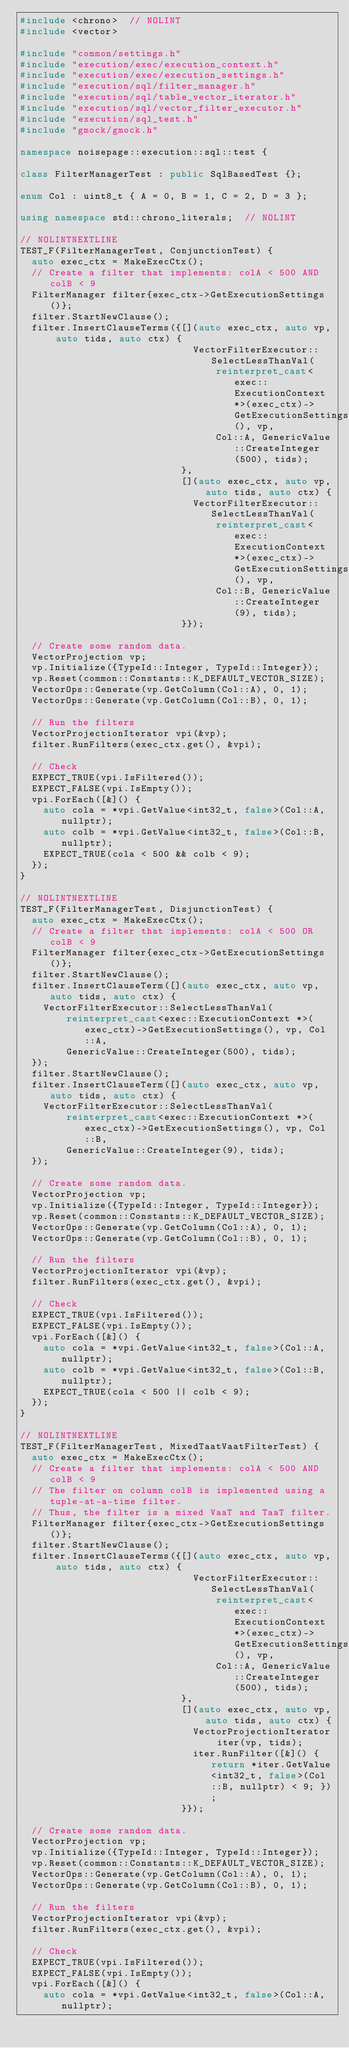Convert code to text. <code><loc_0><loc_0><loc_500><loc_500><_C++_>#include <chrono>  // NOLINT
#include <vector>

#include "common/settings.h"
#include "execution/exec/execution_context.h"
#include "execution/exec/execution_settings.h"
#include "execution/sql/filter_manager.h"
#include "execution/sql/table_vector_iterator.h"
#include "execution/sql/vector_filter_executor.h"
#include "execution/sql_test.h"
#include "gmock/gmock.h"

namespace noisepage::execution::sql::test {

class FilterManagerTest : public SqlBasedTest {};

enum Col : uint8_t { A = 0, B = 1, C = 2, D = 3 };

using namespace std::chrono_literals;  // NOLINT

// NOLINTNEXTLINE
TEST_F(FilterManagerTest, ConjunctionTest) {
  auto exec_ctx = MakeExecCtx();
  // Create a filter that implements: colA < 500 AND colB < 9
  FilterManager filter{exec_ctx->GetExecutionSettings()};
  filter.StartNewClause();
  filter.InsertClauseTerms({[](auto exec_ctx, auto vp, auto tids, auto ctx) {
                              VectorFilterExecutor::SelectLessThanVal(
                                  reinterpret_cast<exec::ExecutionContext *>(exec_ctx)->GetExecutionSettings(), vp,
                                  Col::A, GenericValue::CreateInteger(500), tids);
                            },
                            [](auto exec_ctx, auto vp, auto tids, auto ctx) {
                              VectorFilterExecutor::SelectLessThanVal(
                                  reinterpret_cast<exec::ExecutionContext *>(exec_ctx)->GetExecutionSettings(), vp,
                                  Col::B, GenericValue::CreateInteger(9), tids);
                            }});

  // Create some random data.
  VectorProjection vp;
  vp.Initialize({TypeId::Integer, TypeId::Integer});
  vp.Reset(common::Constants::K_DEFAULT_VECTOR_SIZE);
  VectorOps::Generate(vp.GetColumn(Col::A), 0, 1);
  VectorOps::Generate(vp.GetColumn(Col::B), 0, 1);

  // Run the filters
  VectorProjectionIterator vpi(&vp);
  filter.RunFilters(exec_ctx.get(), &vpi);

  // Check
  EXPECT_TRUE(vpi.IsFiltered());
  EXPECT_FALSE(vpi.IsEmpty());
  vpi.ForEach([&]() {
    auto cola = *vpi.GetValue<int32_t, false>(Col::A, nullptr);
    auto colb = *vpi.GetValue<int32_t, false>(Col::B, nullptr);
    EXPECT_TRUE(cola < 500 && colb < 9);
  });
}

// NOLINTNEXTLINE
TEST_F(FilterManagerTest, DisjunctionTest) {
  auto exec_ctx = MakeExecCtx();
  // Create a filter that implements: colA < 500 OR colB < 9
  FilterManager filter{exec_ctx->GetExecutionSettings()};
  filter.StartNewClause();
  filter.InsertClauseTerm([](auto exec_ctx, auto vp, auto tids, auto ctx) {
    VectorFilterExecutor::SelectLessThanVal(
        reinterpret_cast<exec::ExecutionContext *>(exec_ctx)->GetExecutionSettings(), vp, Col::A,
        GenericValue::CreateInteger(500), tids);
  });
  filter.StartNewClause();
  filter.InsertClauseTerm([](auto exec_ctx, auto vp, auto tids, auto ctx) {
    VectorFilterExecutor::SelectLessThanVal(
        reinterpret_cast<exec::ExecutionContext *>(exec_ctx)->GetExecutionSettings(), vp, Col::B,
        GenericValue::CreateInteger(9), tids);
  });

  // Create some random data.
  VectorProjection vp;
  vp.Initialize({TypeId::Integer, TypeId::Integer});
  vp.Reset(common::Constants::K_DEFAULT_VECTOR_SIZE);
  VectorOps::Generate(vp.GetColumn(Col::A), 0, 1);
  VectorOps::Generate(vp.GetColumn(Col::B), 0, 1);

  // Run the filters
  VectorProjectionIterator vpi(&vp);
  filter.RunFilters(exec_ctx.get(), &vpi);

  // Check
  EXPECT_TRUE(vpi.IsFiltered());
  EXPECT_FALSE(vpi.IsEmpty());
  vpi.ForEach([&]() {
    auto cola = *vpi.GetValue<int32_t, false>(Col::A, nullptr);
    auto colb = *vpi.GetValue<int32_t, false>(Col::B, nullptr);
    EXPECT_TRUE(cola < 500 || colb < 9);
  });
}

// NOLINTNEXTLINE
TEST_F(FilterManagerTest, MixedTaatVaatFilterTest) {
  auto exec_ctx = MakeExecCtx();
  // Create a filter that implements: colA < 500 AND colB < 9
  // The filter on column colB is implemented using a tuple-at-a-time filter.
  // Thus, the filter is a mixed VaaT and TaaT filter.
  FilterManager filter{exec_ctx->GetExecutionSettings()};
  filter.StartNewClause();
  filter.InsertClauseTerms({[](auto exec_ctx, auto vp, auto tids, auto ctx) {
                              VectorFilterExecutor::SelectLessThanVal(
                                  reinterpret_cast<exec::ExecutionContext *>(exec_ctx)->GetExecutionSettings(), vp,
                                  Col::A, GenericValue::CreateInteger(500), tids);
                            },
                            [](auto exec_ctx, auto vp, auto tids, auto ctx) {
                              VectorProjectionIterator iter(vp, tids);
                              iter.RunFilter([&]() { return *iter.GetValue<int32_t, false>(Col::B, nullptr) < 9; });
                            }});

  // Create some random data.
  VectorProjection vp;
  vp.Initialize({TypeId::Integer, TypeId::Integer});
  vp.Reset(common::Constants::K_DEFAULT_VECTOR_SIZE);
  VectorOps::Generate(vp.GetColumn(Col::A), 0, 1);
  VectorOps::Generate(vp.GetColumn(Col::B), 0, 1);

  // Run the filters
  VectorProjectionIterator vpi(&vp);
  filter.RunFilters(exec_ctx.get(), &vpi);

  // Check
  EXPECT_TRUE(vpi.IsFiltered());
  EXPECT_FALSE(vpi.IsEmpty());
  vpi.ForEach([&]() {
    auto cola = *vpi.GetValue<int32_t, false>(Col::A, nullptr);</code> 